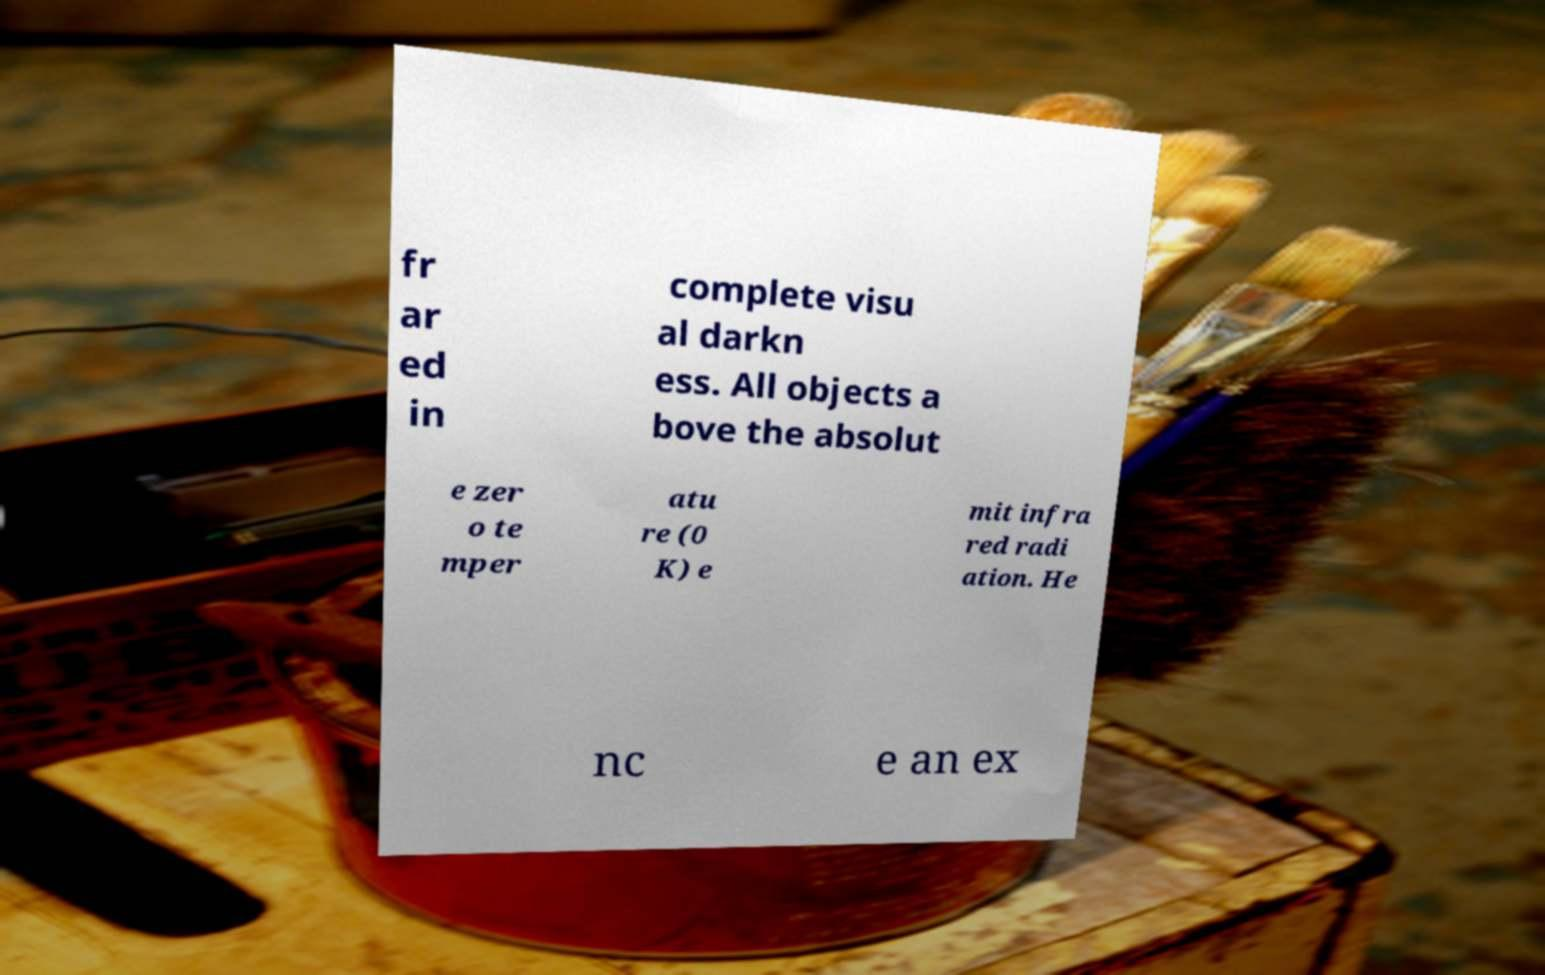Please read and relay the text visible in this image. What does it say? fr ar ed in complete visu al darkn ess. All objects a bove the absolut e zer o te mper atu re (0 K) e mit infra red radi ation. He nc e an ex 